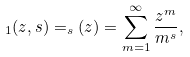Convert formula to latex. <formula><loc_0><loc_0><loc_500><loc_500>_ { 1 } ( z , s ) = _ { s } ( z ) = \sum _ { m = 1 } ^ { \infty } \frac { z ^ { m } } { m ^ { s } } ,</formula> 